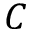Convert formula to latex. <formula><loc_0><loc_0><loc_500><loc_500>C</formula> 